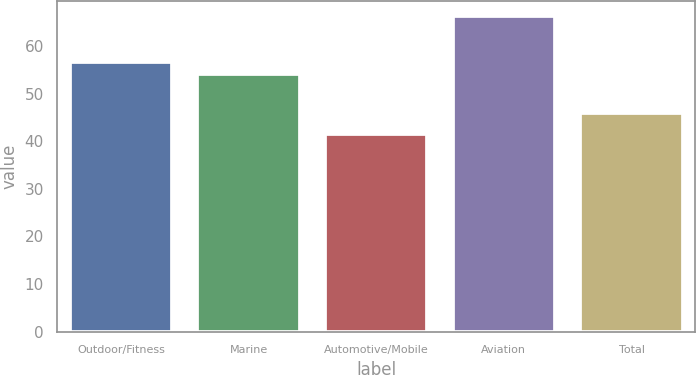Convert chart to OTSL. <chart><loc_0><loc_0><loc_500><loc_500><bar_chart><fcel>Outdoor/Fitness<fcel>Marine<fcel>Automotive/Mobile<fcel>Aviation<fcel>Total<nl><fcel>56.66<fcel>54.2<fcel>41.6<fcel>66.2<fcel>46<nl></chart> 